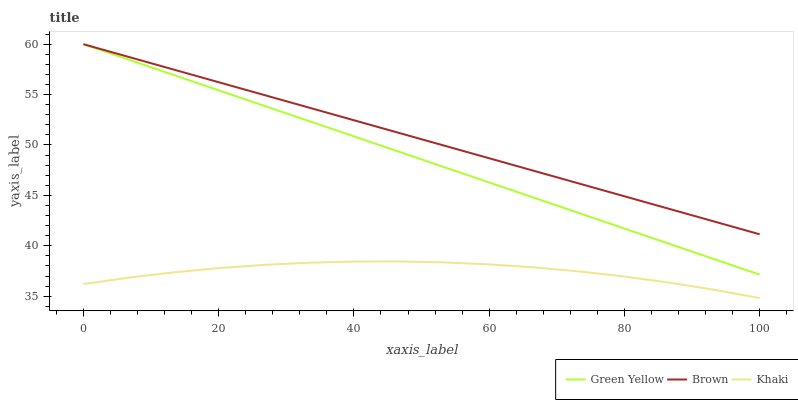Does Khaki have the minimum area under the curve?
Answer yes or no. Yes. Does Brown have the maximum area under the curve?
Answer yes or no. Yes. Does Green Yellow have the minimum area under the curve?
Answer yes or no. No. Does Green Yellow have the maximum area under the curve?
Answer yes or no. No. Is Brown the smoothest?
Answer yes or no. Yes. Is Khaki the roughest?
Answer yes or no. Yes. Is Green Yellow the smoothest?
Answer yes or no. No. Is Green Yellow the roughest?
Answer yes or no. No. Does Khaki have the lowest value?
Answer yes or no. Yes. Does Green Yellow have the lowest value?
Answer yes or no. No. Does Green Yellow have the highest value?
Answer yes or no. Yes. Does Khaki have the highest value?
Answer yes or no. No. Is Khaki less than Brown?
Answer yes or no. Yes. Is Green Yellow greater than Khaki?
Answer yes or no. Yes. Does Green Yellow intersect Brown?
Answer yes or no. Yes. Is Green Yellow less than Brown?
Answer yes or no. No. Is Green Yellow greater than Brown?
Answer yes or no. No. Does Khaki intersect Brown?
Answer yes or no. No. 